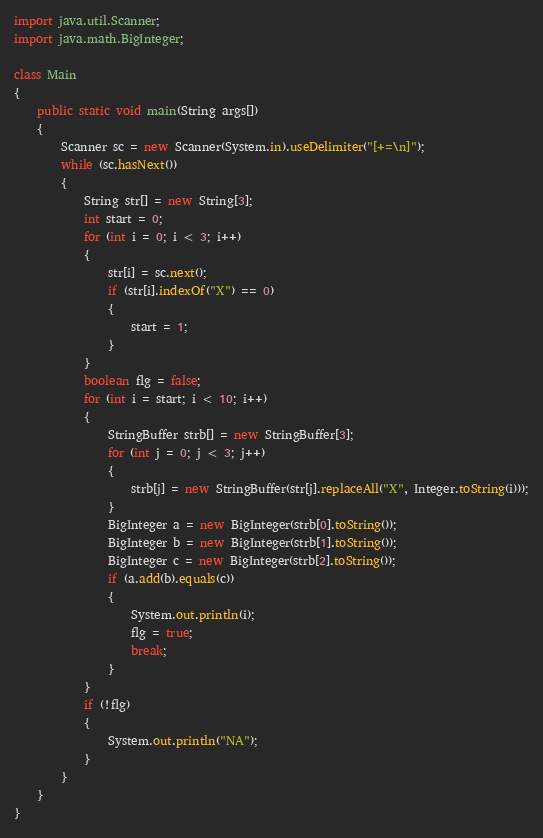Convert code to text. <code><loc_0><loc_0><loc_500><loc_500><_Java_>import java.util.Scanner;
import java.math.BigInteger;

class Main
{
	public static void main(String args[])
	{
		Scanner sc = new Scanner(System.in).useDelimiter("[+=\n]");
		while (sc.hasNext())
		{
			String str[] = new String[3];
			int start = 0;
			for (int i = 0; i < 3; i++)
			{
				str[i] = sc.next();
				if (str[i].indexOf("X") == 0)
				{
					start = 1;
				}
			}
			boolean flg = false;
			for (int i = start; i < 10; i++)
			{
				StringBuffer strb[] = new StringBuffer[3];
				for (int j = 0; j < 3; j++)
				{
					strb[j] = new StringBuffer(str[j].replaceAll("X", Integer.toString(i)));
				}
				BigInteger a = new BigInteger(strb[0].toString());
				BigInteger b = new BigInteger(strb[1].toString());
				BigInteger c = new BigInteger(strb[2].toString());
				if (a.add(b).equals(c))
				{
					System.out.println(i);
					flg = true;
					break;
				}
			}
			if (!flg)
			{
				System.out.println("NA");
			}
		}
	}
}</code> 